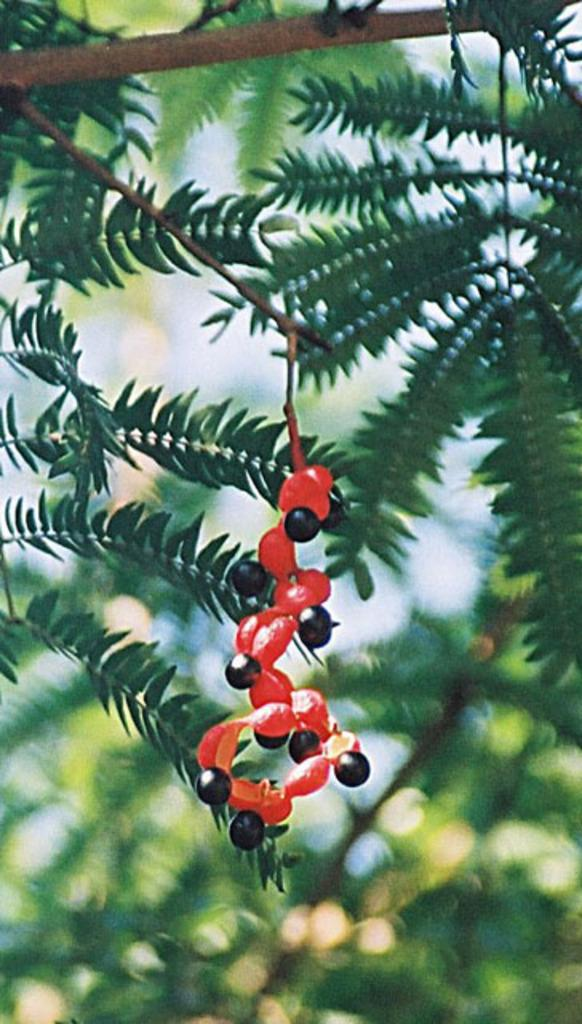What is present on the tree branch in the image? There is an object on the tree branch in the image. Can you describe the object on the tree branch? Unfortunately, the image does not provide enough detail to describe the object on the tree branch. Is the sky visible in the image? The sky may be visible behind the tree in the image. What type of fruit is hanging from the tree branch in the image? There is no fruit hanging from the tree branch in the image. Is the tree branch made of steel in the image? There is no indication in the image that the tree branch is made of steel. 